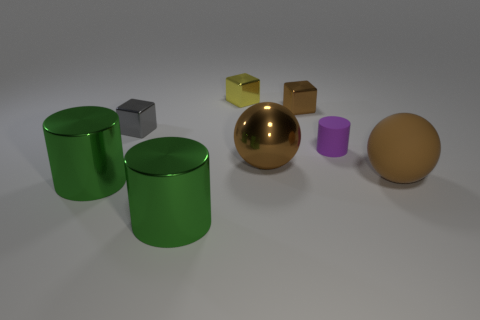The yellow cube is what size?
Offer a very short reply. Small. What shape is the tiny brown thing that is the same material as the small gray block?
Offer a terse response. Cube. There is a tiny thing that is on the left side of the yellow metal thing; is its shape the same as the small brown object?
Keep it short and to the point. Yes. What number of things are big blue rubber objects or metal objects?
Offer a terse response. 6. There is a cube that is to the right of the small gray cube and in front of the yellow object; what material is it made of?
Ensure brevity in your answer.  Metal. Do the gray object and the matte cylinder have the same size?
Keep it short and to the point. Yes. There is a rubber object behind the large brown thing to the left of the brown rubber thing; how big is it?
Provide a short and direct response. Small. What number of big things are both to the right of the gray shiny cube and in front of the brown matte ball?
Your answer should be compact. 1. Are there any big brown metallic things that are left of the green metal object that is on the left side of the cube that is on the left side of the small yellow shiny object?
Ensure brevity in your answer.  No. The brown object that is the same size as the yellow metal block is what shape?
Offer a very short reply. Cube. 